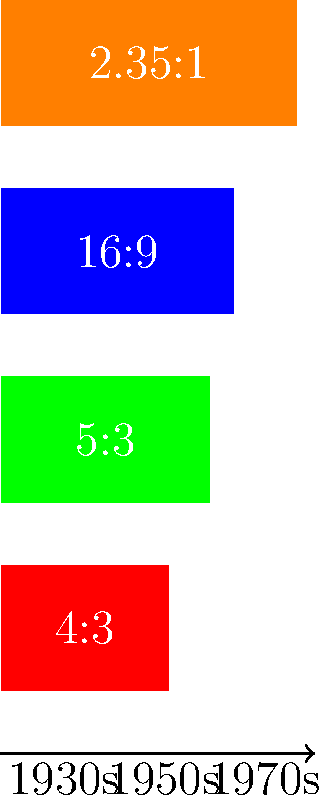Based on the visual comparison of film frames shown above, which aspect ratio became increasingly popular in British cinema during the 1950s and 1960s, partly as a response to the rise of television? To answer this question, we need to analyze the evolution of aspect ratios in British cinema:

1. The 4:3 (1.33:1) aspect ratio was standard in early cinema, including the 1930s.

2. In the 1950s, cinema faced competition from television, which used the 4:3 ratio. To differentiate themselves, filmmakers began experimenting with wider formats.

3. The 5:3 (1.66:1) aspect ratio, shown in green, became popular in European cinema, including British films, during the 1950s and 1960s.

4. This wider format offered a more expansive view than television without being as extreme as some American widescreen formats like CinemaScope (2.35:1).

5. The 5:3 ratio was a compromise between the traditional 4:3 and wider formats, making it suitable for both theatrical release and later television broadcast.

6. While 16:9 (1.85:1) and 2.35:1 ratios were also used, the 5:3 ratio was particularly favored in British and European cinema during this period.

Therefore, the aspect ratio that became increasingly popular in British cinema during the 1950s and 1960s, partly as a response to the rise of television, was the 5:3 (1.66:1) ratio.
Answer: 5:3 (1.66:1) aspect ratio 